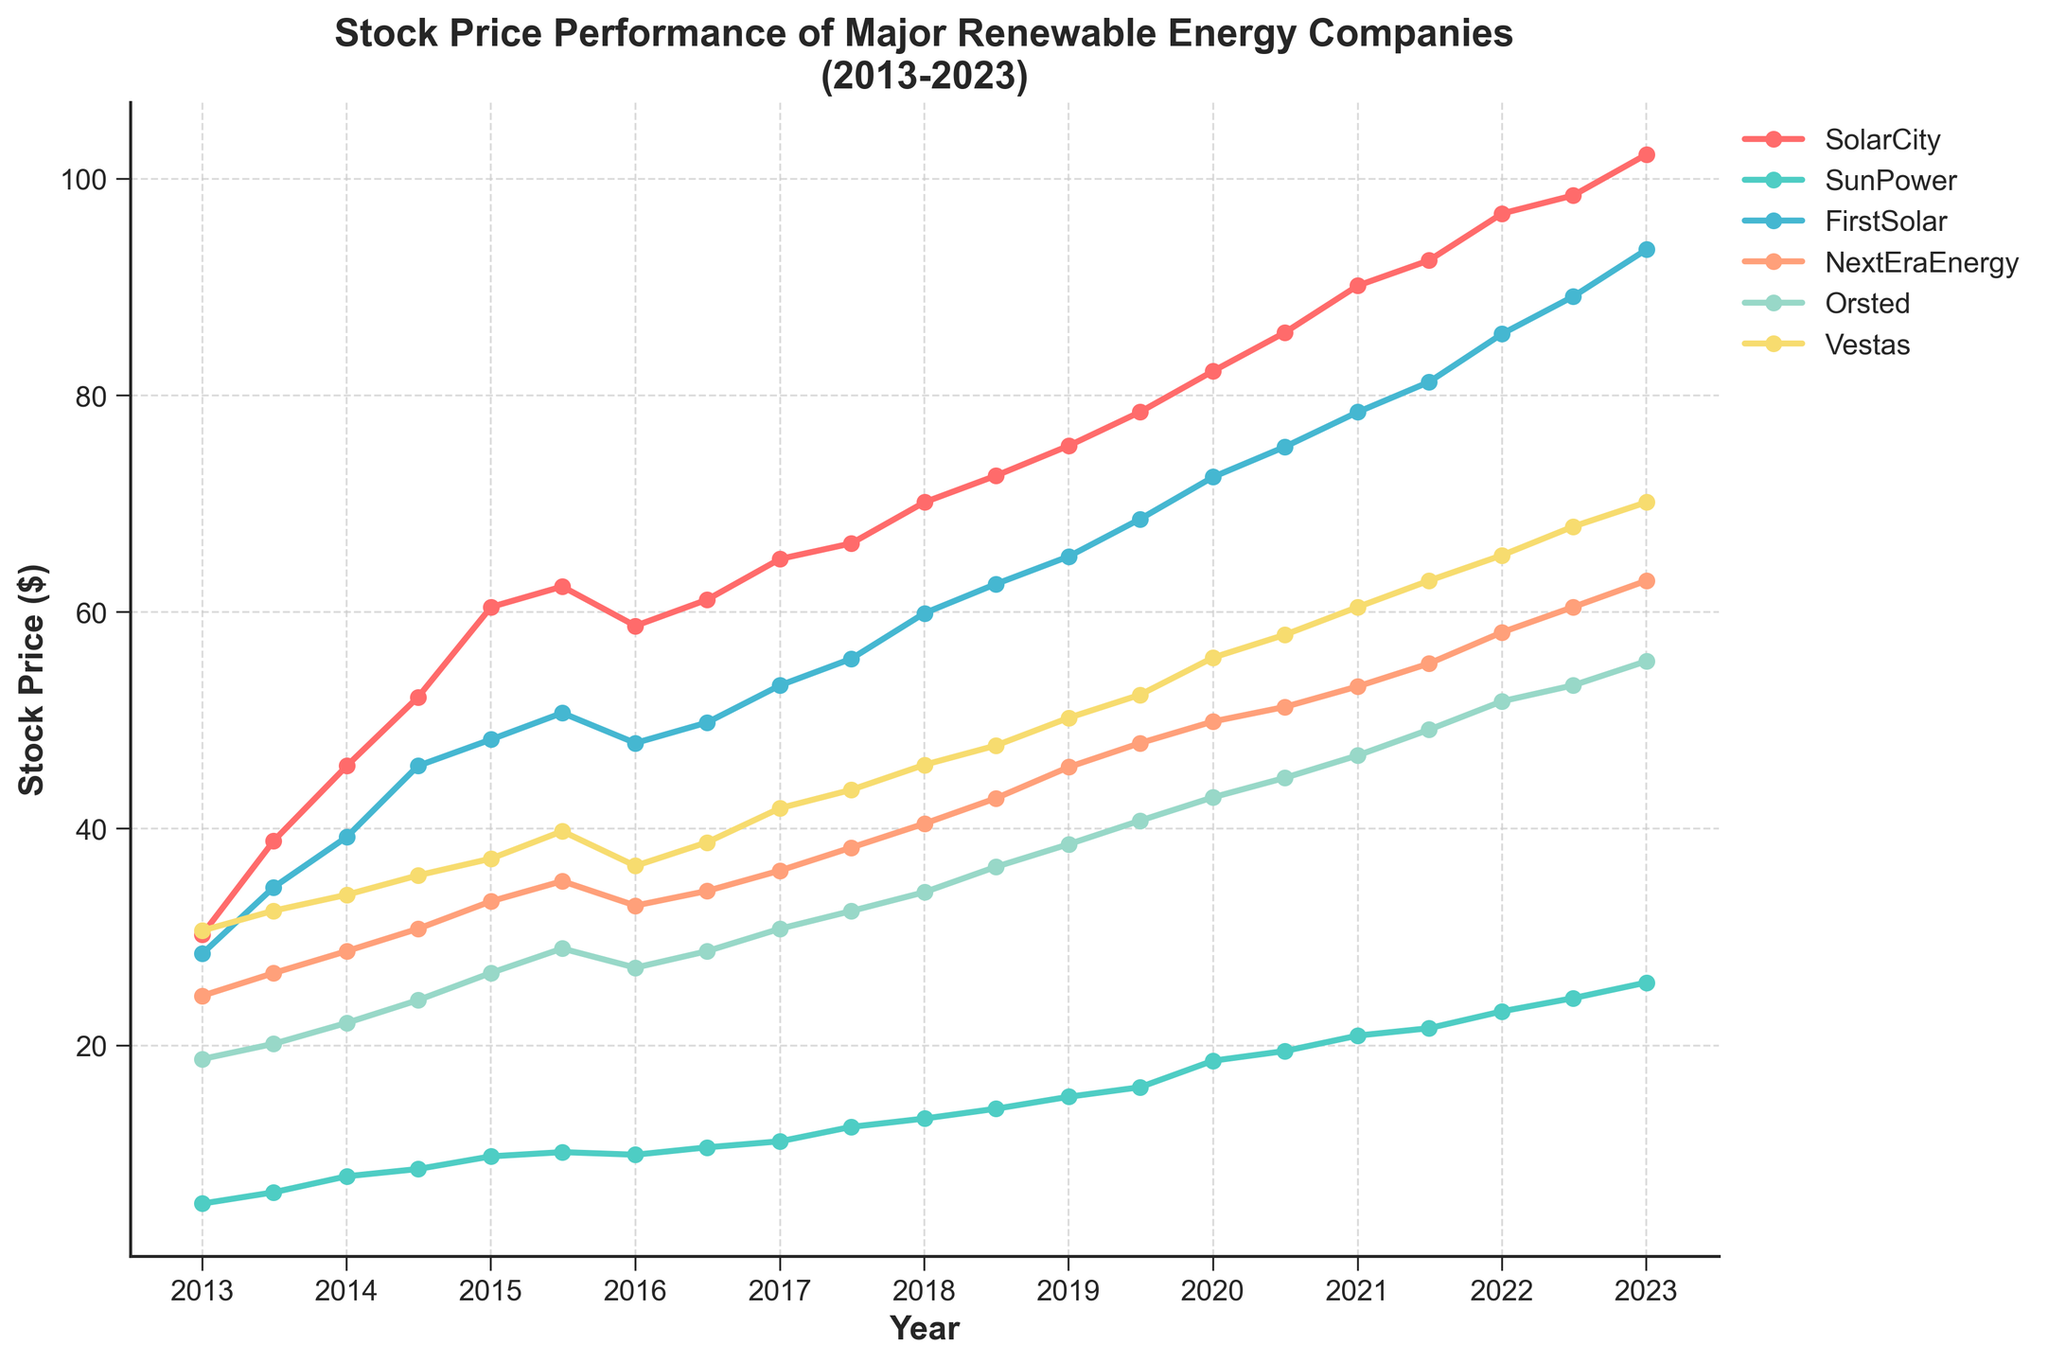What is the title of the plot? The title is located at the top of the plot and clearly describes the figure.
Answer: Stock Price Performance of Major Renewable Energy Companies (2013-2023) How many companies' stock prices are depicted in the figure? Count the number of distinct lines or the number of labels in the legend.
Answer: 6 Which company had the highest stock price at the beginning of 2013? Look at the values on the y-axis for the first data point in 2013 for each company and identify the highest one.
Answer: SolarCity What is the general trend of Vestas' stock price over the past 10 years? Observe the direction of the data points for Vestas from 2013 to 2023.
Answer: Increasing Which two companies had the most similar stock price trends over the last 10 years? Compare the lines for all companies and identify the two whose lines follow similar patterns.
Answer: NextEraEnergy and Orsted Did any company's stock price decline between 2013 and 2023? Look at the first and last data points for each company and compare them to see if any have decreased.
Answer: No Which company had the greatest overall percentage increase in stock price from 2013 to 2023? Calculate the percentage increase for each company: ((2023 price - 2013 price) / 2013 price) * 100, then compare the results.
Answer: SunPower In what year did SunPower's stock price start to consistently rise without a drop? Identify the year on the x-axis where the stock price for SunPower shows a continuous upward trend without any significant dip thereafter.
Answer: 2016 What was the stock price of FirstSolar in July 2017, and how does it compare to its stock price at the same time in 2022? Identify the stock prices of FirstSolar in July 2017 and July 2022 and calculate the difference.
Answer: July 2017: $55.67, July 2022: $89.12, difference: $33.45 Which company's stock price witnessed the sharpest increase between any two consecutive data points? Calculate the difference for each pair of consecutive points for all companies and identify the one with the largest difference.
Answer: SunPower (Jan 2020 to Jul 2020) What are the y-axis labels representing? The y-axis labels represent the measurement unit used for the stock prices of the companies.
Answer: Stock Price ($) 